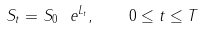Convert formula to latex. <formula><loc_0><loc_0><loc_500><loc_500>S _ { t } = S _ { 0 } \ e ^ { L _ { t } } , \quad 0 \leq t \leq T</formula> 